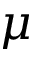<formula> <loc_0><loc_0><loc_500><loc_500>\mu</formula> 